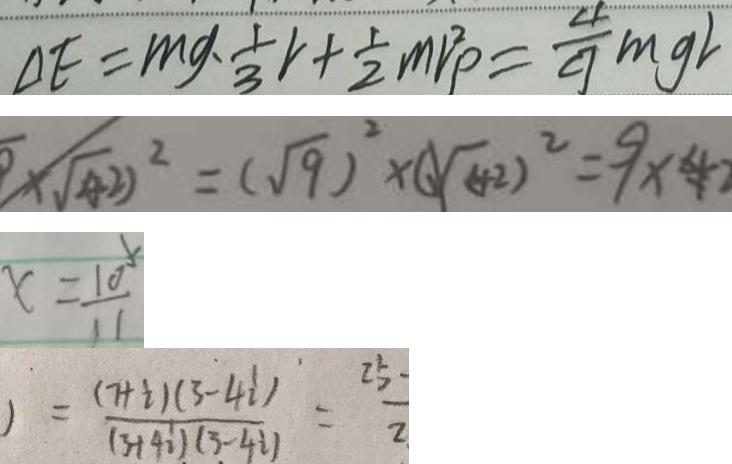Convert formula to latex. <formula><loc_0><loc_0><loc_500><loc_500>\Delta E = m g \cdot \frac { 1 } { 3 } v + \frac { 1 } { 2 } m v ^ { 2 } p = \frac { 4 } { 9 } m g v 
 5 \times \sqrt { ( 4 2 ) } ^ { 2 } = ( \sqrt { 9 } ) ^ { 2 } \times ( \sqrt { 4 } ) ^ { 2 } = 9 \times 4 
 x = \frac { 1 0 } { 1 1 } 
 ) = \frac { ( 7 + i ) ( 3 - 4 i ) } { ( 3 + 4 i ) ( 3 - 4 i ) } = \frac { 2 5 } { 2 }</formula> 